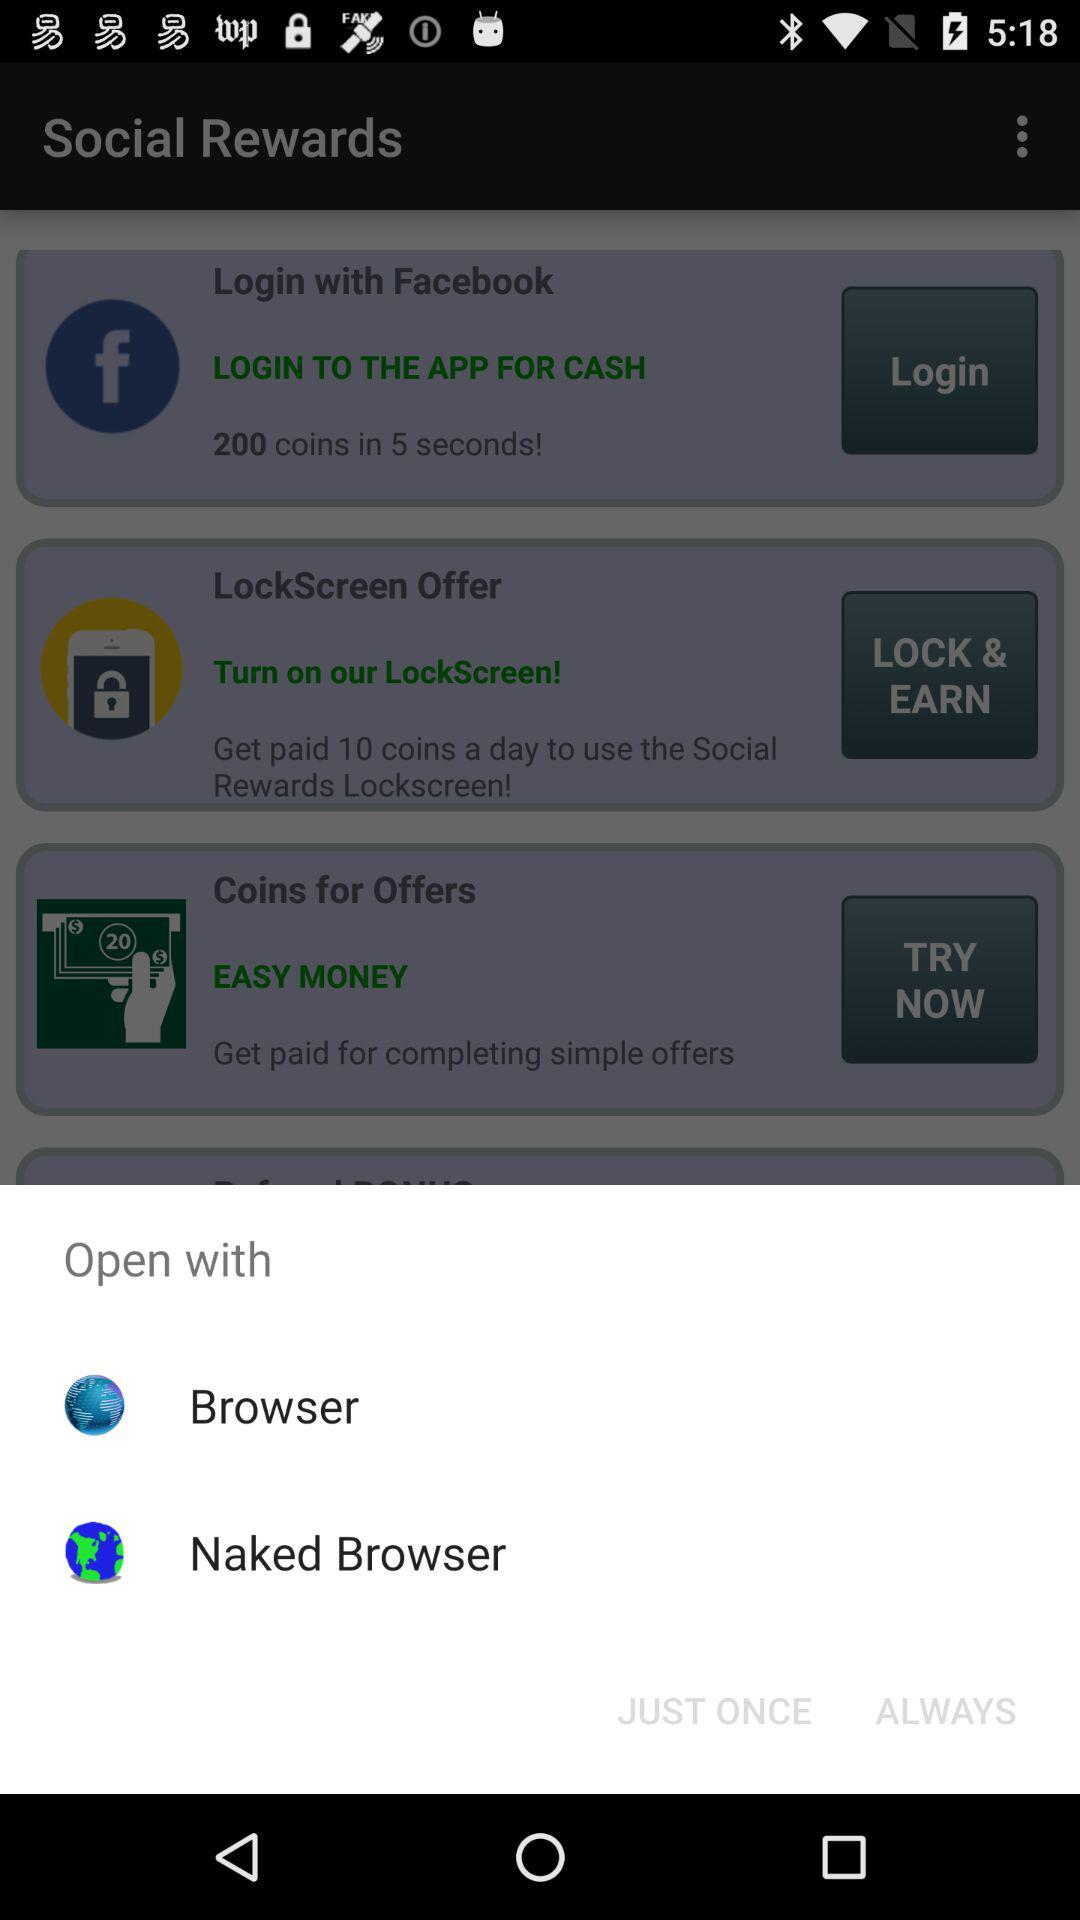With which applications can we open? You can open with "Naked Browser". 